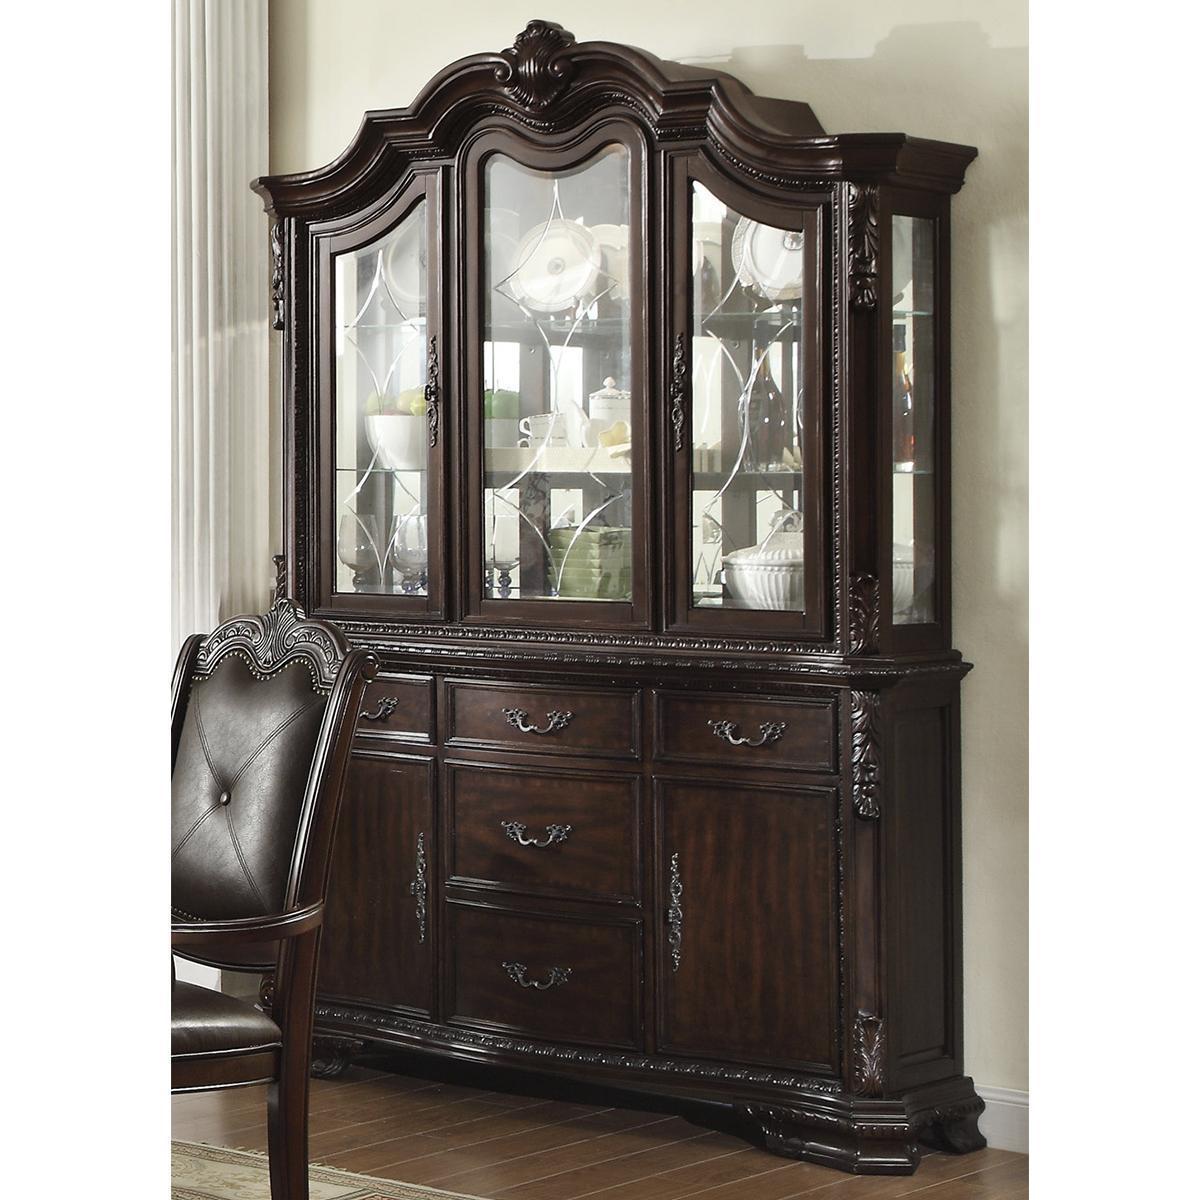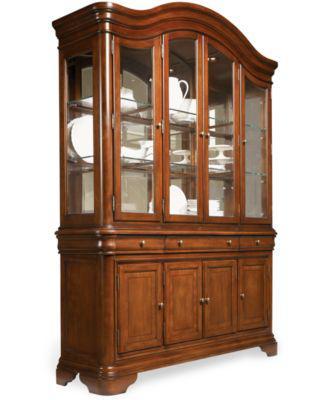The first image is the image on the left, the second image is the image on the right. Given the left and right images, does the statement "One of the cabinets is empty." hold true? Answer yes or no. No. 